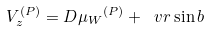<formula> <loc_0><loc_0><loc_500><loc_500>V _ { z } ^ { ( P ) } = D { \mu _ { W } } ^ { ( P ) } + \ v r \sin b</formula> 